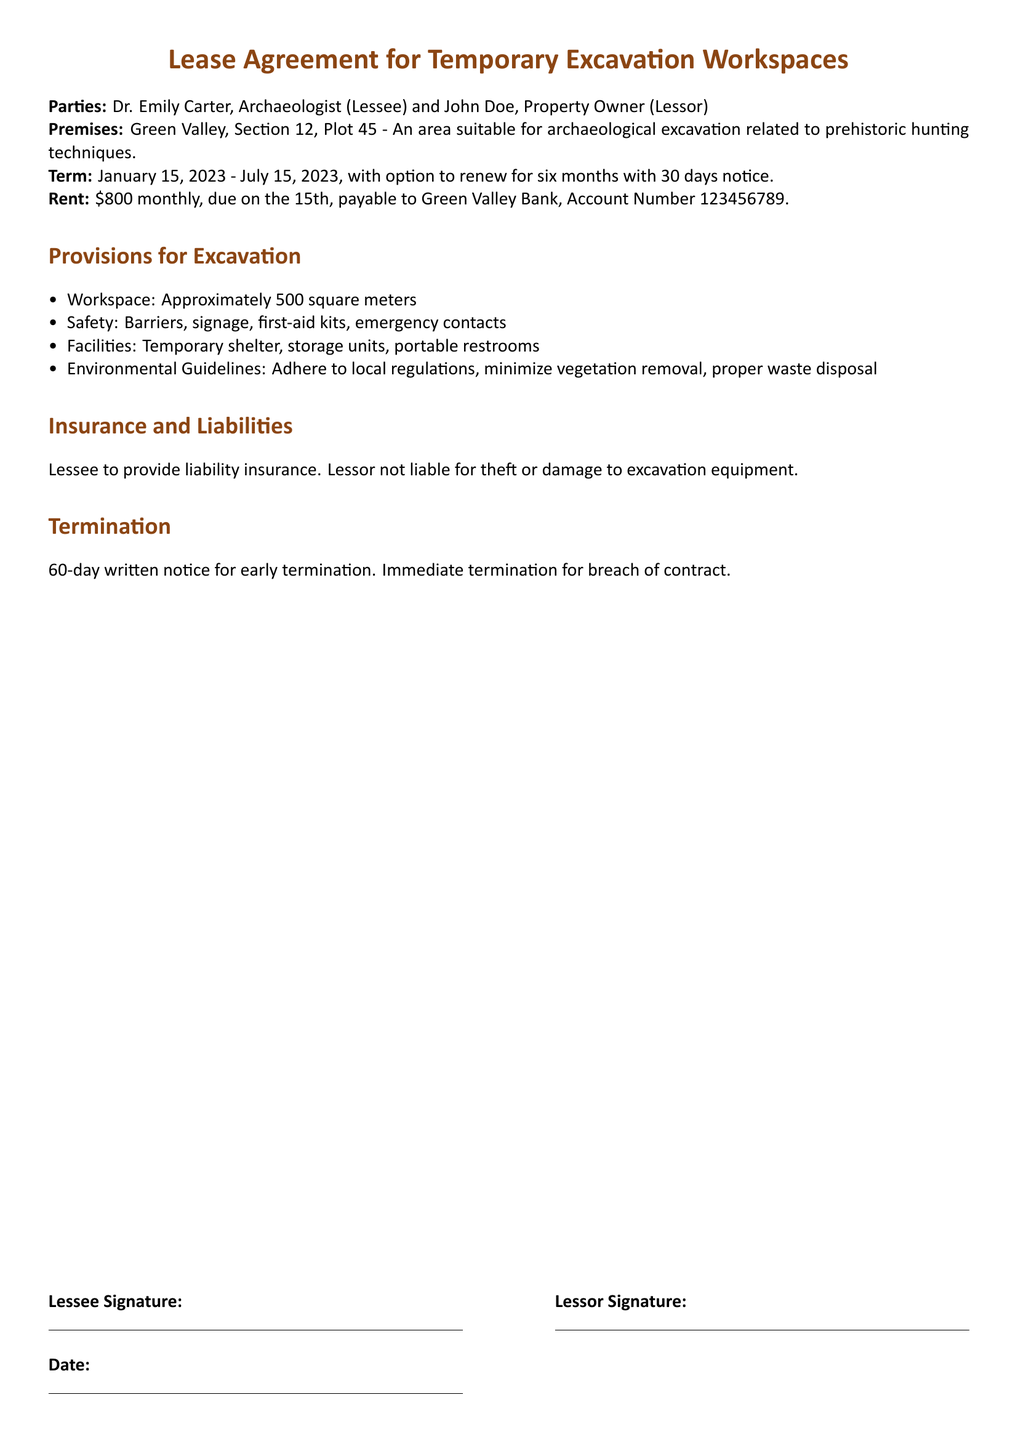What is the name of the Lessee? The Lessee is named in the document as Dr. Emily Carter.
Answer: Dr. Emily Carter What is the rental amount per month? The document states that the monthly rent is \$800.
Answer: \$800 What is the lease term start date? The start date of the lease term is specified in the document.
Answer: January 15, 2023 What is the area of the workspace provided? The workspace area is listed in the provisions section of the document.
Answer: Approximately 500 square meters What is the notice period for early termination? The notice period for early termination is indicated in the termination section.
Answer: 60-day written notice What is the maximum duration for lease renewal? The document outlines the duration of lease renewal under the term section.
Answer: Six months What type of insurance must the Lessee provide? The document specifies the type of insurance required of the Lessee in the insurance section.
Answer: Liability insurance Who is not liable for theft or damage? The liability information in the document indicates who holds this responsibility.
Answer: Lessor What facilities are included in the leased property? The document details specific facilities provided within the leased property.
Answer: Temporary shelter, storage units, portable restrooms 